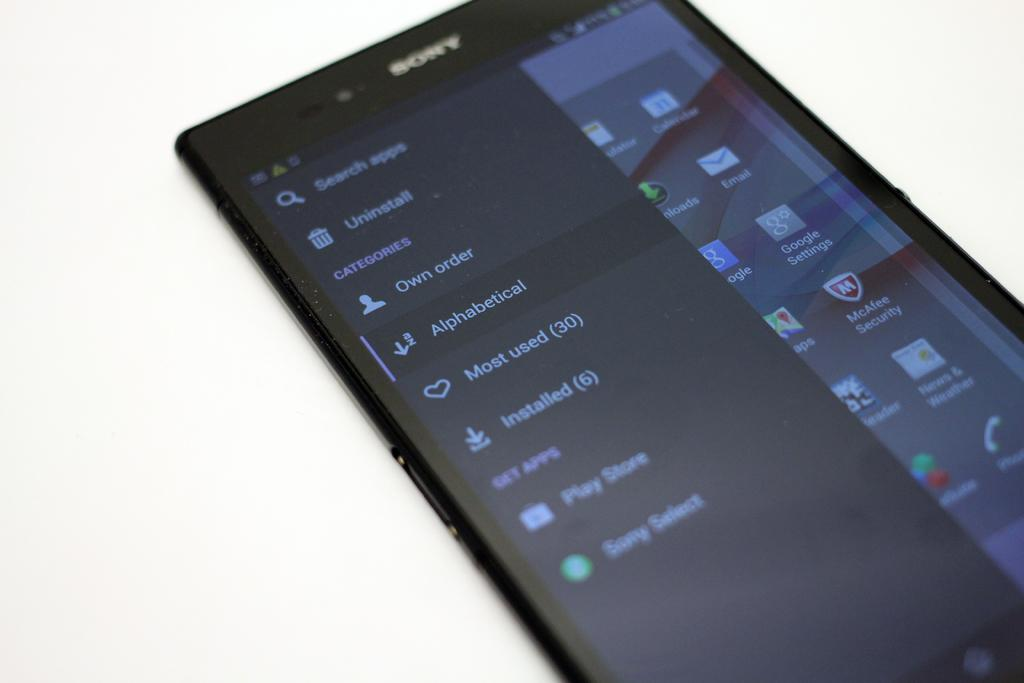<image>
Describe the image concisely. A Sony phone screen has an uninstall icon near the top. 